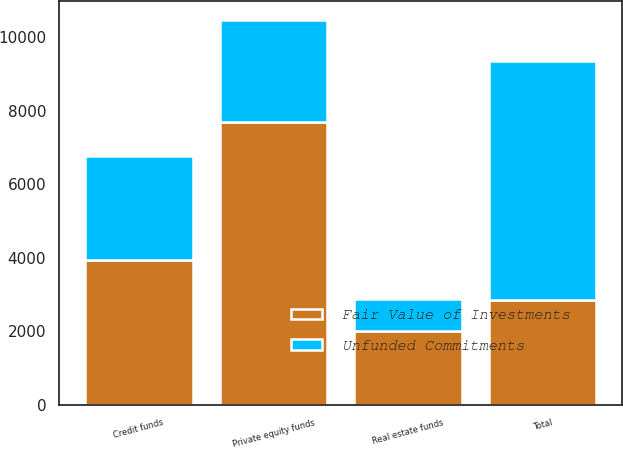Convert chart to OTSL. <chart><loc_0><loc_0><loc_500><loc_500><stacked_bar_chart><ecel><fcel>Private equity funds<fcel>Credit funds<fcel>Real estate funds<fcel>Total<nl><fcel>Fair Value of Investments<fcel>7680<fcel>3927<fcel>2006<fcel>2843<nl><fcel>Unfunded Commitments<fcel>2778<fcel>2843<fcel>870<fcel>6491<nl></chart> 